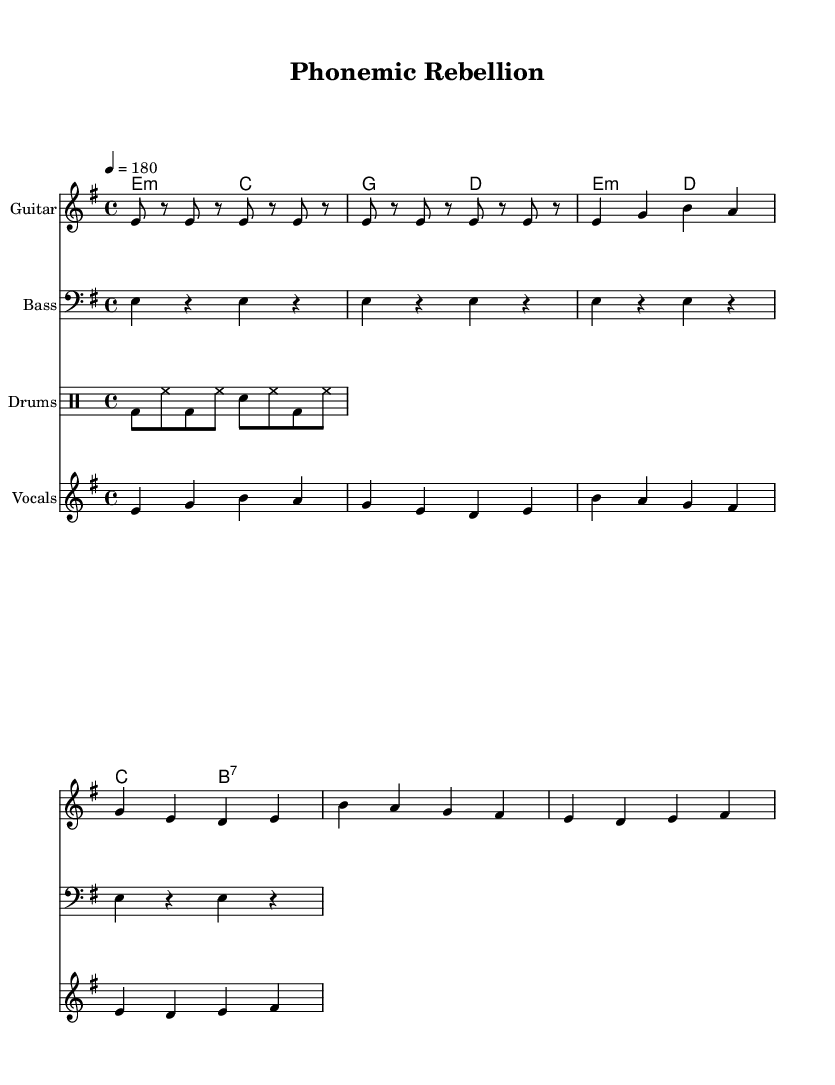What is the key signature of this music? The key signature is E minor, which is indicated by one sharp (F#) in the music. This can be deduced from the global section where \key e \minor is specified.
Answer: E minor What is the time signature of this music? The time signature is 4/4, as shown in the global section of the code with \time 4/4. This means there are four beats per measure, and it is typical for many punk songs.
Answer: 4/4 What tempo marking is indicated in this sheet music? The tempo marking is quarter note equals 180 beats per minute, found in the global section with \tempo 4 = 180. This indicates a fast tempo, common in punk music.
Answer: 180 How many measures does the guitar riff repeat? The guitar riff repeats twice, as indicated by the \repeat unfold 2 statement in the code. Each repeat indicates a full cycle of the riff.
Answer: 2 What are the prominent themes expressed in the lyrics of the chorus? The lyrics of the chorus refer to a "phonemic rebellion" and "linguistic evolution," showcasing the punk theme of challenging norms. This interpretation can be derived from the chorus words in the \lyricmode section.
Answer: phonemic rebellion, linguistic evolution Which chords are played during the verse? The chords played during the verse are E minor and C major, as specified in the \verseChords section. The arrangement of these two chords defines the harmonic structure of the verse.
Answer: E minor, C major What is the rhythmic pattern for the bass riff? The rhythmic pattern for the bass riff consists of whole notes (e4 r4), where each note lasts for a full measure. This indicates a steady, driving rhythm typical in punk bass lines.
Answer: whole notes 